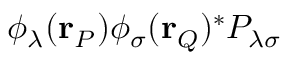Convert formula to latex. <formula><loc_0><loc_0><loc_500><loc_500>\phi _ { \lambda } ( r _ { P } ) \phi _ { \sigma } ( r _ { Q } ) ^ { * } P _ { \lambda \sigma }</formula> 